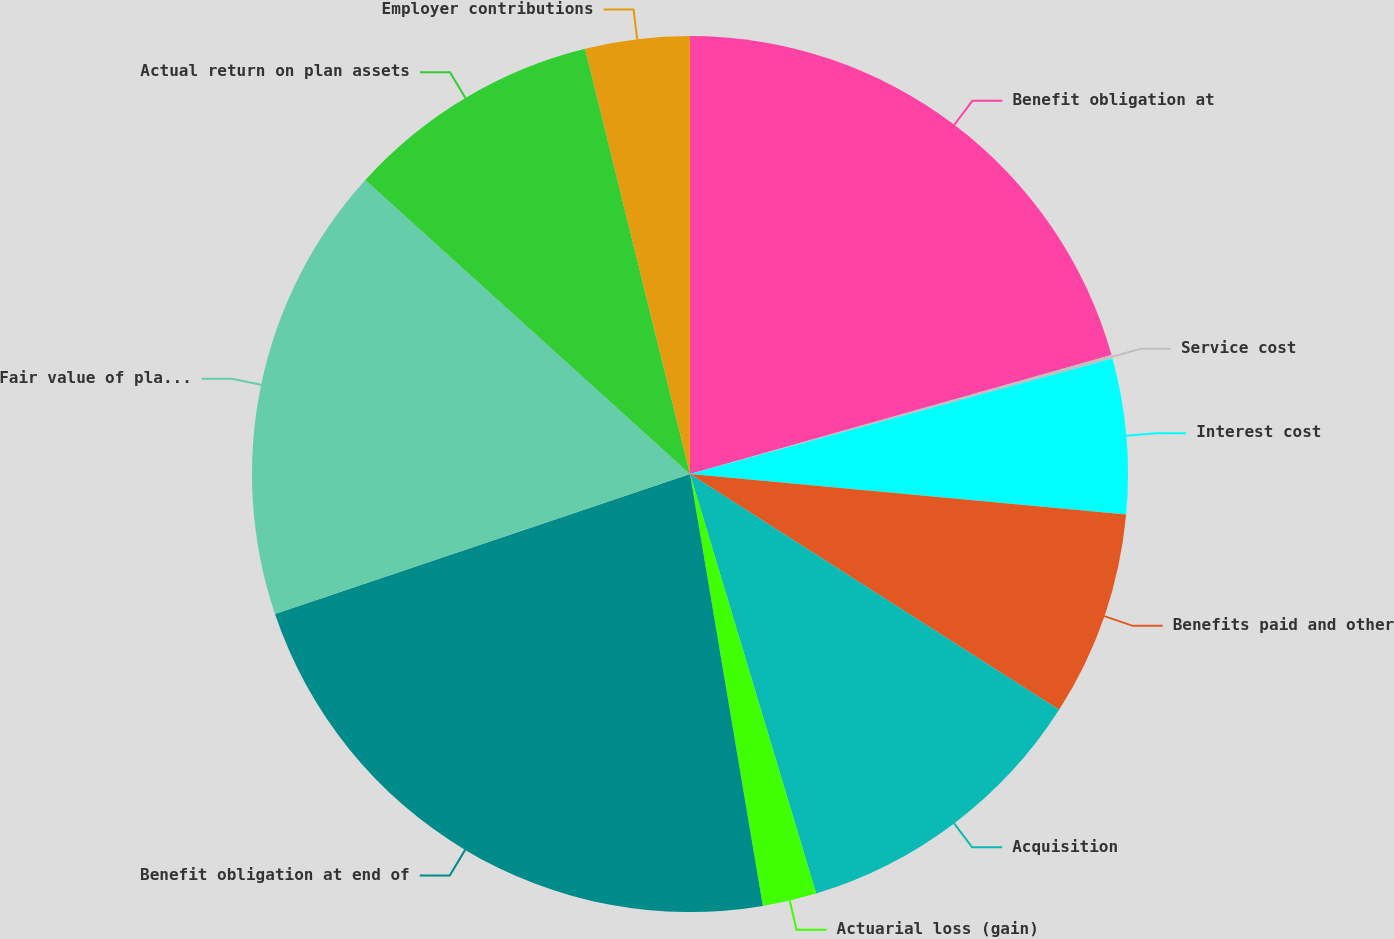Convert chart to OTSL. <chart><loc_0><loc_0><loc_500><loc_500><pie_chart><fcel>Benefit obligation at<fcel>Service cost<fcel>Interest cost<fcel>Benefits paid and other<fcel>Acquisition<fcel>Actuarial loss (gain)<fcel>Benefit obligation at end of<fcel>Fair value of plan assets at<fcel>Actual return on plan assets<fcel>Employer contributions<nl><fcel>20.62%<fcel>0.13%<fcel>5.72%<fcel>7.58%<fcel>11.3%<fcel>1.99%<fcel>22.48%<fcel>16.89%<fcel>9.44%<fcel>3.85%<nl></chart> 